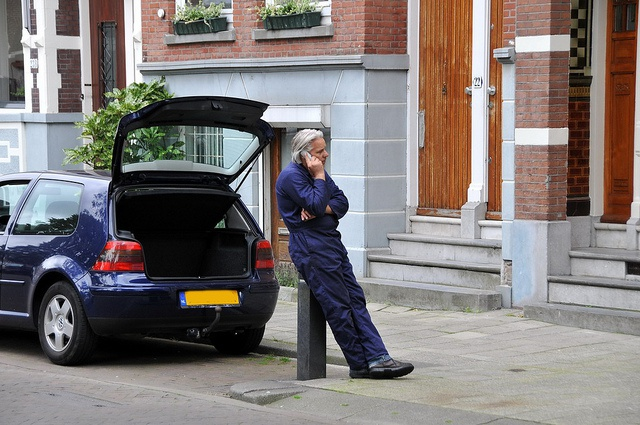Describe the objects in this image and their specific colors. I can see car in gray, black, darkgray, and navy tones, people in gray, black, navy, and darkgray tones, potted plant in gray, darkgray, darkgreen, and black tones, potted plant in gray, black, darkgray, and olive tones, and potted plant in gray, black, darkgray, and olive tones in this image. 